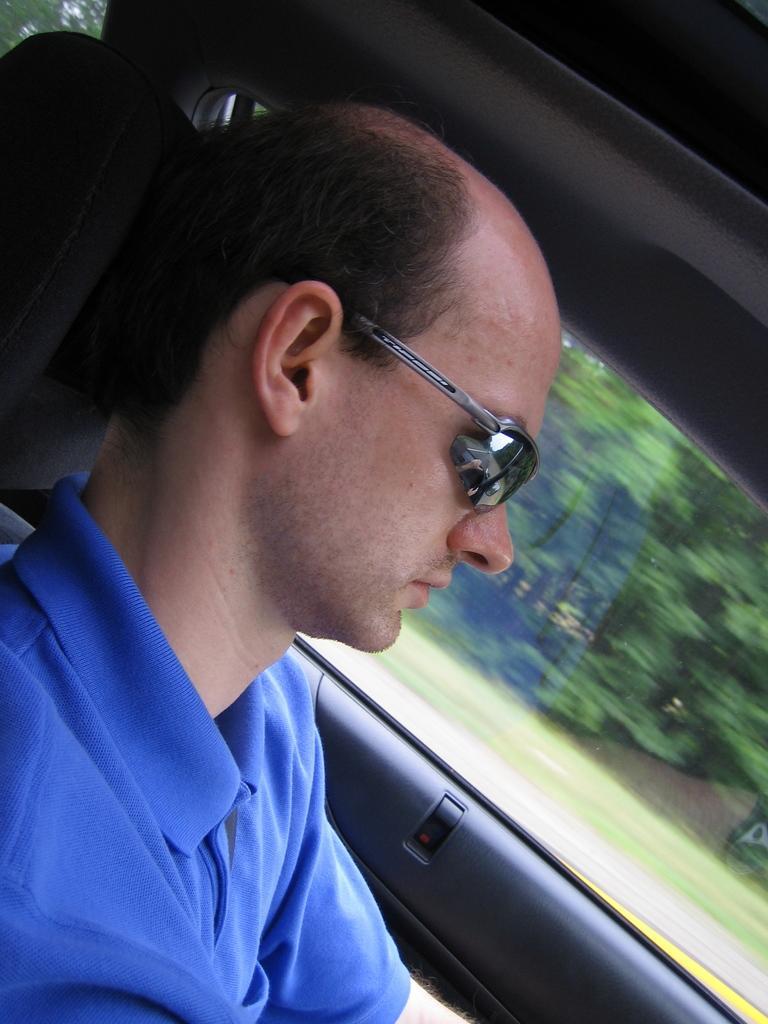Can you describe this image briefly? In this picture there is a man with blue t-shirt is sitting inside the vehicle. Behind the mirror there are trees and there is a reflection of a hand on the mirror. At the bottom there is a road and there is grass. 